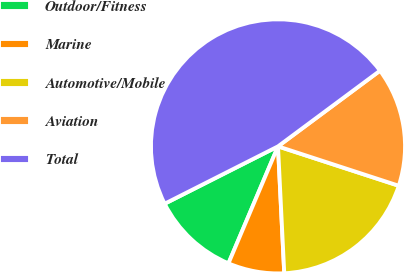Convert chart to OTSL. <chart><loc_0><loc_0><loc_500><loc_500><pie_chart><fcel>Outdoor/Fitness<fcel>Marine<fcel>Automotive/Mobile<fcel>Aviation<fcel>Total<nl><fcel>11.17%<fcel>7.16%<fcel>19.2%<fcel>15.18%<fcel>47.3%<nl></chart> 